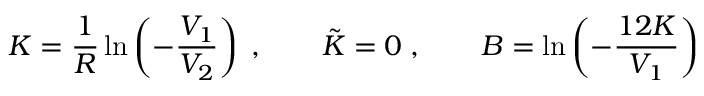Convert formula to latex. <formula><loc_0><loc_0><loc_500><loc_500>K = \frac { 1 } { R } \ln \left ( - \frac { V _ { 1 } } { V _ { 2 } } \right ) \, , \quad \tilde { K } = 0 \, , \quad B = \ln \left ( - \frac { 1 2 K } { V _ { 1 } } \right )</formula> 